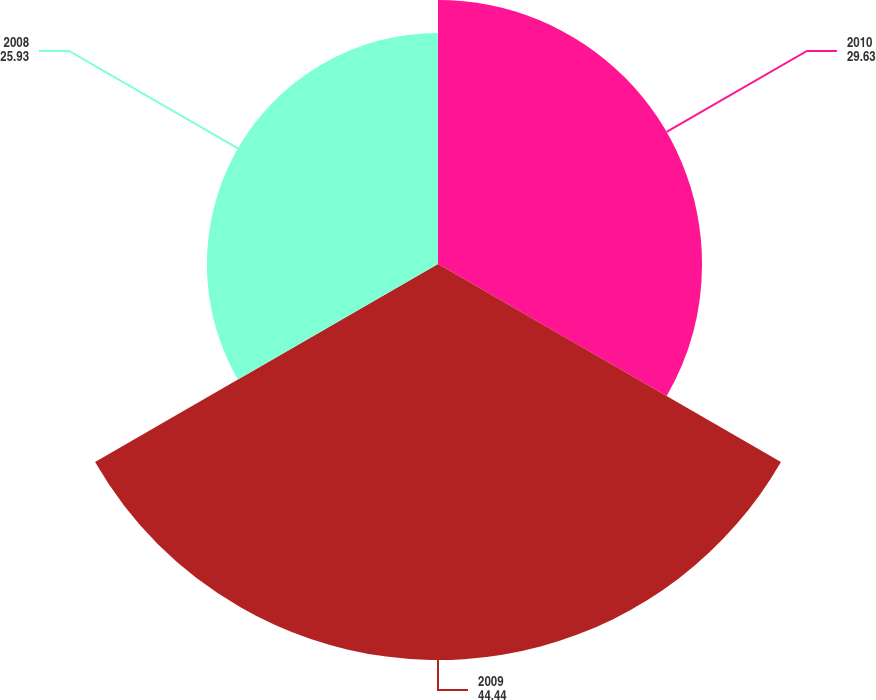<chart> <loc_0><loc_0><loc_500><loc_500><pie_chart><fcel>2010<fcel>2009<fcel>2008<nl><fcel>29.63%<fcel>44.44%<fcel>25.93%<nl></chart> 